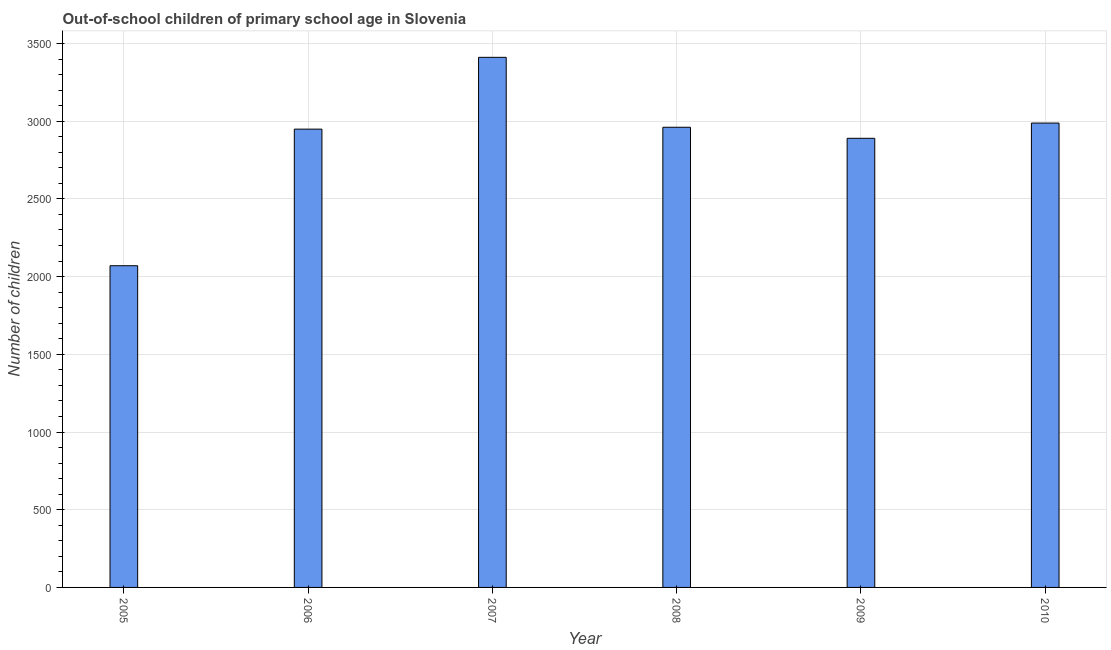What is the title of the graph?
Keep it short and to the point. Out-of-school children of primary school age in Slovenia. What is the label or title of the Y-axis?
Give a very brief answer. Number of children. What is the number of out-of-school children in 2010?
Give a very brief answer. 2988. Across all years, what is the maximum number of out-of-school children?
Offer a terse response. 3411. Across all years, what is the minimum number of out-of-school children?
Provide a succinct answer. 2070. What is the sum of the number of out-of-school children?
Keep it short and to the point. 1.73e+04. What is the difference between the number of out-of-school children in 2005 and 2008?
Offer a terse response. -891. What is the average number of out-of-school children per year?
Provide a short and direct response. 2878. What is the median number of out-of-school children?
Your answer should be compact. 2955. In how many years, is the number of out-of-school children greater than 2900 ?
Keep it short and to the point. 4. Do a majority of the years between 2008 and 2006 (inclusive) have number of out-of-school children greater than 300 ?
Offer a very short reply. Yes. What is the ratio of the number of out-of-school children in 2007 to that in 2009?
Your response must be concise. 1.18. Is the number of out-of-school children in 2006 less than that in 2008?
Offer a terse response. Yes. Is the difference between the number of out-of-school children in 2008 and 2010 greater than the difference between any two years?
Make the answer very short. No. What is the difference between the highest and the second highest number of out-of-school children?
Provide a short and direct response. 423. Is the sum of the number of out-of-school children in 2008 and 2010 greater than the maximum number of out-of-school children across all years?
Offer a terse response. Yes. What is the difference between the highest and the lowest number of out-of-school children?
Your response must be concise. 1341. What is the difference between two consecutive major ticks on the Y-axis?
Keep it short and to the point. 500. Are the values on the major ticks of Y-axis written in scientific E-notation?
Provide a succinct answer. No. What is the Number of children of 2005?
Provide a succinct answer. 2070. What is the Number of children of 2006?
Your answer should be compact. 2949. What is the Number of children of 2007?
Provide a succinct answer. 3411. What is the Number of children in 2008?
Offer a terse response. 2961. What is the Number of children in 2009?
Provide a succinct answer. 2890. What is the Number of children of 2010?
Your response must be concise. 2988. What is the difference between the Number of children in 2005 and 2006?
Your answer should be compact. -879. What is the difference between the Number of children in 2005 and 2007?
Provide a succinct answer. -1341. What is the difference between the Number of children in 2005 and 2008?
Your answer should be compact. -891. What is the difference between the Number of children in 2005 and 2009?
Provide a short and direct response. -820. What is the difference between the Number of children in 2005 and 2010?
Your answer should be compact. -918. What is the difference between the Number of children in 2006 and 2007?
Ensure brevity in your answer.  -462. What is the difference between the Number of children in 2006 and 2009?
Keep it short and to the point. 59. What is the difference between the Number of children in 2006 and 2010?
Keep it short and to the point. -39. What is the difference between the Number of children in 2007 and 2008?
Provide a succinct answer. 450. What is the difference between the Number of children in 2007 and 2009?
Provide a succinct answer. 521. What is the difference between the Number of children in 2007 and 2010?
Your response must be concise. 423. What is the difference between the Number of children in 2008 and 2010?
Offer a terse response. -27. What is the difference between the Number of children in 2009 and 2010?
Your answer should be very brief. -98. What is the ratio of the Number of children in 2005 to that in 2006?
Offer a very short reply. 0.7. What is the ratio of the Number of children in 2005 to that in 2007?
Offer a very short reply. 0.61. What is the ratio of the Number of children in 2005 to that in 2008?
Your response must be concise. 0.7. What is the ratio of the Number of children in 2005 to that in 2009?
Your response must be concise. 0.72. What is the ratio of the Number of children in 2005 to that in 2010?
Provide a succinct answer. 0.69. What is the ratio of the Number of children in 2006 to that in 2007?
Provide a short and direct response. 0.86. What is the ratio of the Number of children in 2006 to that in 2008?
Provide a short and direct response. 1. What is the ratio of the Number of children in 2006 to that in 2009?
Offer a very short reply. 1.02. What is the ratio of the Number of children in 2007 to that in 2008?
Your answer should be very brief. 1.15. What is the ratio of the Number of children in 2007 to that in 2009?
Your answer should be very brief. 1.18. What is the ratio of the Number of children in 2007 to that in 2010?
Give a very brief answer. 1.14. What is the ratio of the Number of children in 2008 to that in 2010?
Offer a very short reply. 0.99. 